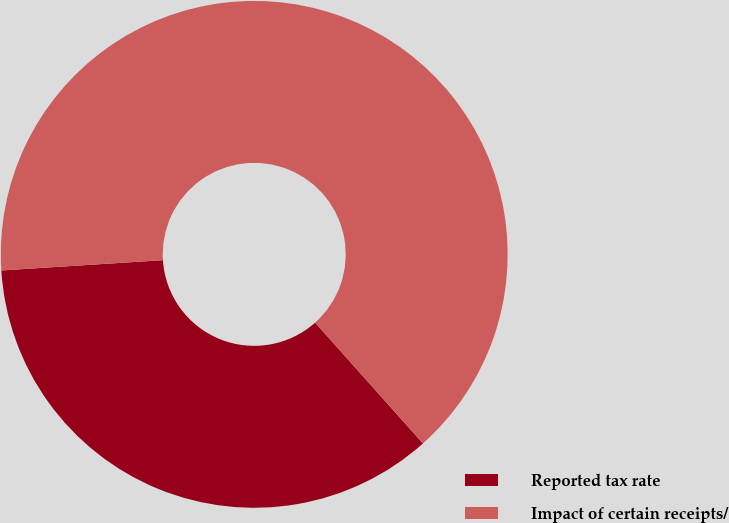Convert chart. <chart><loc_0><loc_0><loc_500><loc_500><pie_chart><fcel>Reported tax rate<fcel>Impact of certain receipts/<nl><fcel>35.58%<fcel>64.42%<nl></chart> 